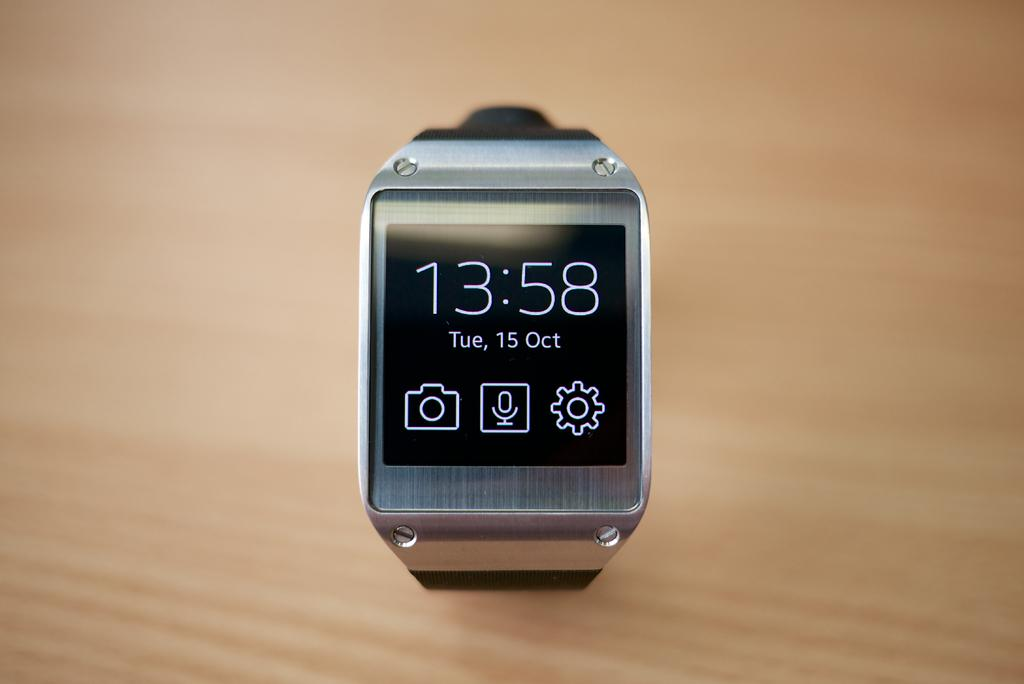<image>
Create a compact narrative representing the image presented. A digital watch with 13:58 on the face 